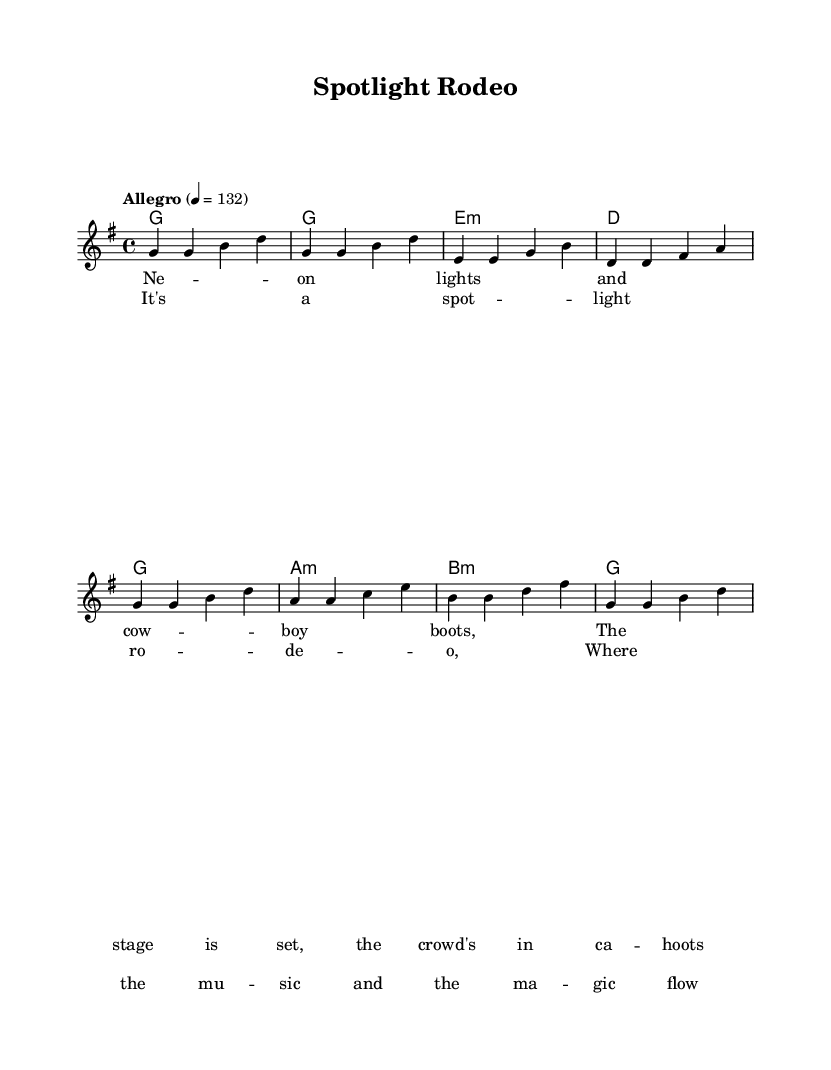What is the key signature of this music? The key signature is G major, which contains one sharp. This can be identified from the key signature at the beginning of the piece in the staff notation.
Answer: G major What is the time signature of this music? The time signature is 4/4, seen at the beginning of the piece, indicating four beats per measure.
Answer: 4/4 What is the tempo marking for this piece? The tempo marking is "Allegro", with a metronome setting of quarter note = 132, indicated at the start of the score.
Answer: Allegro How many measures are in the verse section? There are four measures in the verse section, which can be counted directly from the melody part provided.
Answer: four What is the last chord of the chorus? The last chord of the chorus is G major, which is concluded based on the chord progression shown for that section.
Answer: G What lyrical theme is emphasized in the chorus? The theme emphasized in the chorus revolves around a celebration of music and its excitement, as suggested by the lyrics "Where the music and the magic flow".
Answer: celebration What type of rhythm predominates in the melody? The rhythm in the melody is predominantly quarter notes, which can be identified as each note in the melody is written as a quarter note throughout the sections.
Answer: quarter notes 